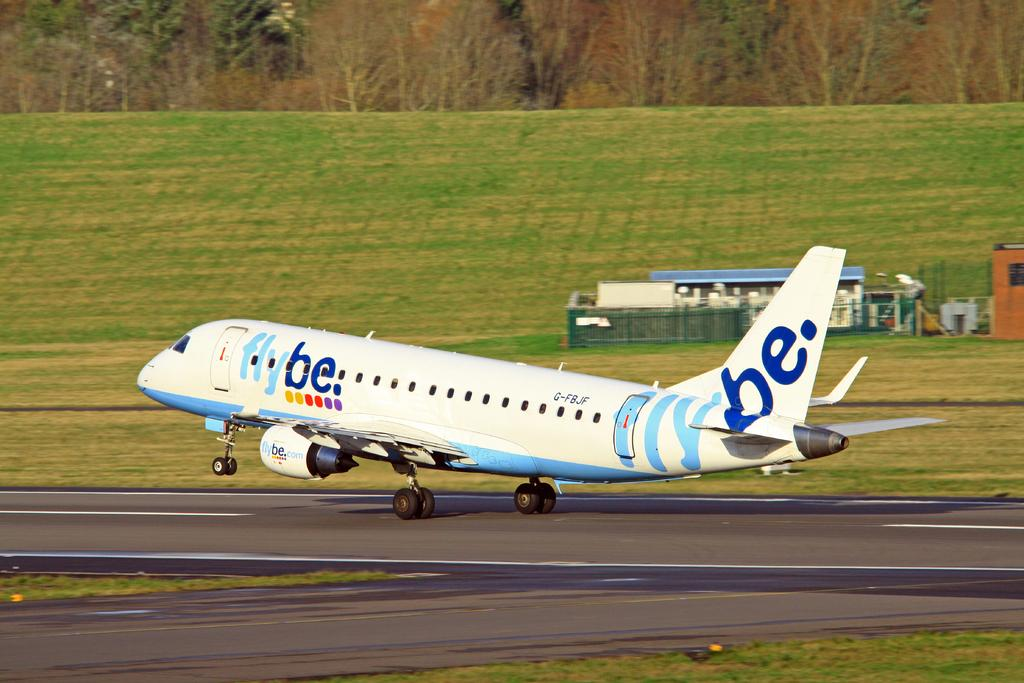<image>
Provide a brief description of the given image. a white and blue plane with flybe written on it 